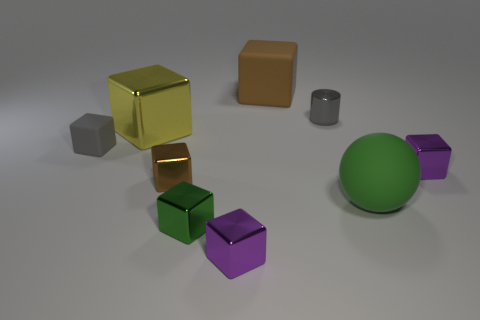Are any purple metallic blocks visible?
Your answer should be very brief. Yes. There is a small purple cube right of the gray shiny thing; what is its material?
Offer a terse response. Metal. What is the material of the cylinder that is the same color as the tiny matte object?
Your answer should be compact. Metal. How many tiny objects are either green rubber balls or metallic objects?
Provide a short and direct response. 5. The big rubber ball has what color?
Provide a succinct answer. Green. Is there a cube that is to the left of the metallic block that is to the right of the brown rubber thing?
Make the answer very short. Yes. Are there fewer matte blocks that are on the right side of the green metal block than big spheres?
Your answer should be very brief. No. Do the tiny cube to the left of the small brown cube and the ball have the same material?
Your answer should be very brief. Yes. There is a cylinder that is the same material as the tiny brown cube; what color is it?
Your response must be concise. Gray. Are there fewer large rubber balls that are behind the small brown cube than big matte objects that are to the left of the small gray metallic thing?
Keep it short and to the point. Yes. 